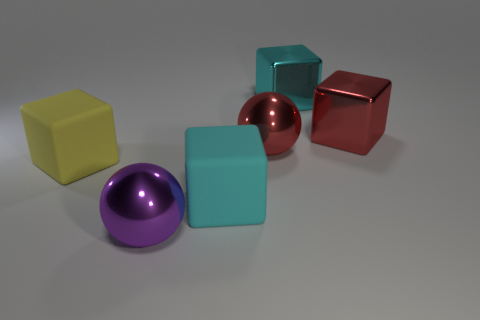Subtract 1 cubes. How many cubes are left? 3 Subtract all gray balls. Subtract all yellow cylinders. How many balls are left? 2 Add 1 green rubber cubes. How many objects exist? 7 Subtract all spheres. How many objects are left? 4 Add 2 big cyan metal objects. How many big cyan metal objects exist? 3 Subtract 0 blue balls. How many objects are left? 6 Subtract all metal balls. Subtract all yellow objects. How many objects are left? 3 Add 4 purple metallic balls. How many purple metallic balls are left? 5 